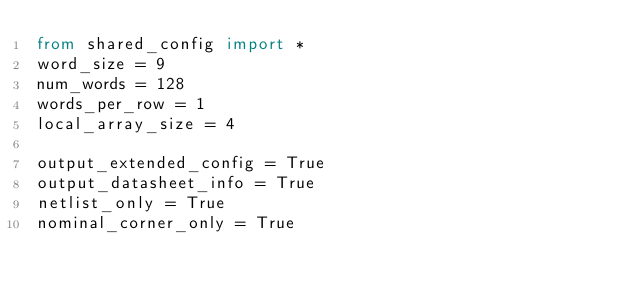Convert code to text. <code><loc_0><loc_0><loc_500><loc_500><_Python_>from shared_config import *
word_size = 9
num_words = 128
words_per_row = 1
local_array_size = 4

output_extended_config = True
output_datasheet_info = True
netlist_only = True
nominal_corner_only = True
</code> 